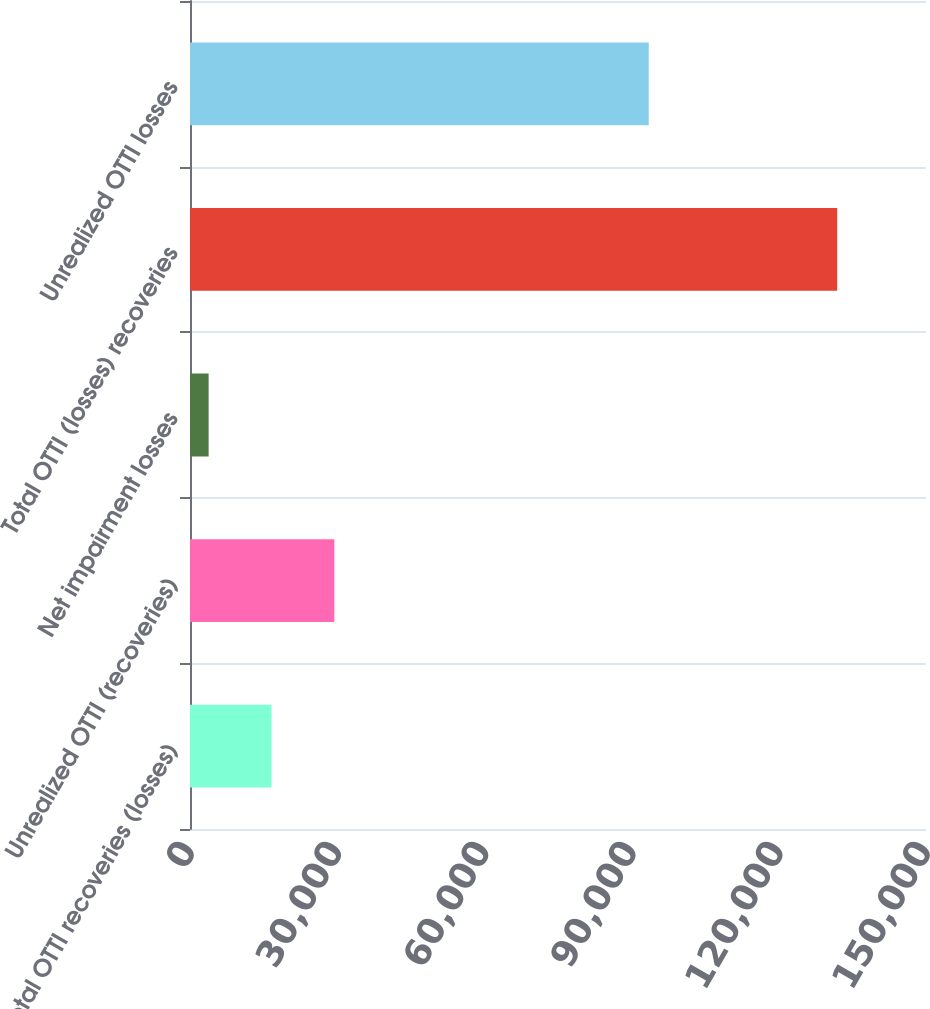<chart> <loc_0><loc_0><loc_500><loc_500><bar_chart><fcel>Total OTTI recoveries (losses)<fcel>Unrealized OTTI (recoveries)<fcel>Net impairment losses<fcel>Total OTTI (losses) recoveries<fcel>Unrealized OTTI losses<nl><fcel>16608.4<fcel>29418.8<fcel>3798<fcel>131902<fcel>93491<nl></chart> 